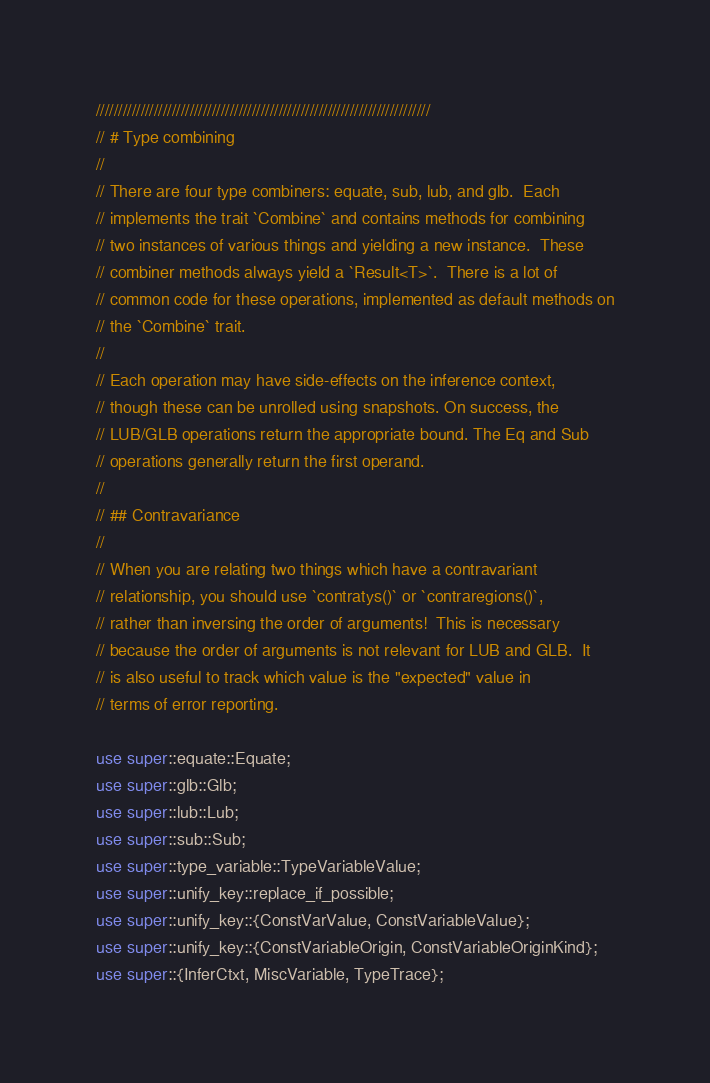<code> <loc_0><loc_0><loc_500><loc_500><_Rust_>///////////////////////////////////////////////////////////////////////////
// # Type combining
//
// There are four type combiners: equate, sub, lub, and glb.  Each
// implements the trait `Combine` and contains methods for combining
// two instances of various things and yielding a new instance.  These
// combiner methods always yield a `Result<T>`.  There is a lot of
// common code for these operations, implemented as default methods on
// the `Combine` trait.
//
// Each operation may have side-effects on the inference context,
// though these can be unrolled using snapshots. On success, the
// LUB/GLB operations return the appropriate bound. The Eq and Sub
// operations generally return the first operand.
//
// ## Contravariance
//
// When you are relating two things which have a contravariant
// relationship, you should use `contratys()` or `contraregions()`,
// rather than inversing the order of arguments!  This is necessary
// because the order of arguments is not relevant for LUB and GLB.  It
// is also useful to track which value is the "expected" value in
// terms of error reporting.

use super::equate::Equate;
use super::glb::Glb;
use super::lub::Lub;
use super::sub::Sub;
use super::type_variable::TypeVariableValue;
use super::unify_key::replace_if_possible;
use super::unify_key::{ConstVarValue, ConstVariableValue};
use super::unify_key::{ConstVariableOrigin, ConstVariableOriginKind};
use super::{InferCtxt, MiscVariable, TypeTrace};
</code> 